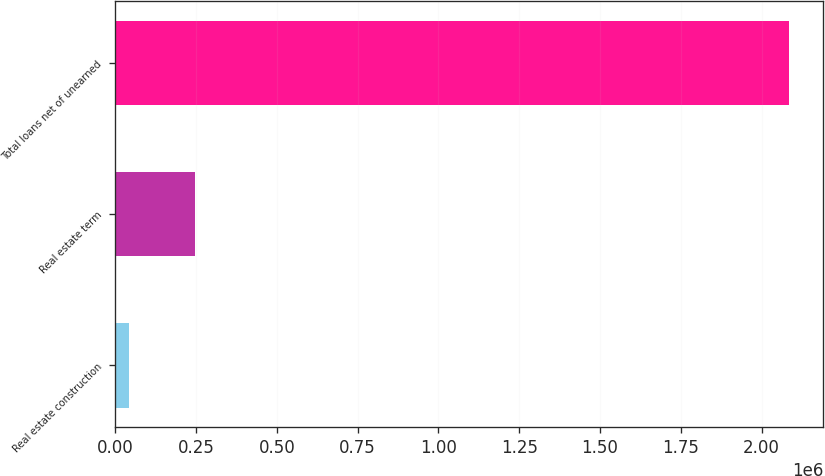Convert chart. <chart><loc_0><loc_0><loc_500><loc_500><bar_chart><fcel>Real estate construction<fcel>Real estate term<fcel>Total loans net of unearned<nl><fcel>43178<fcel>247468<fcel>2.08608e+06<nl></chart> 